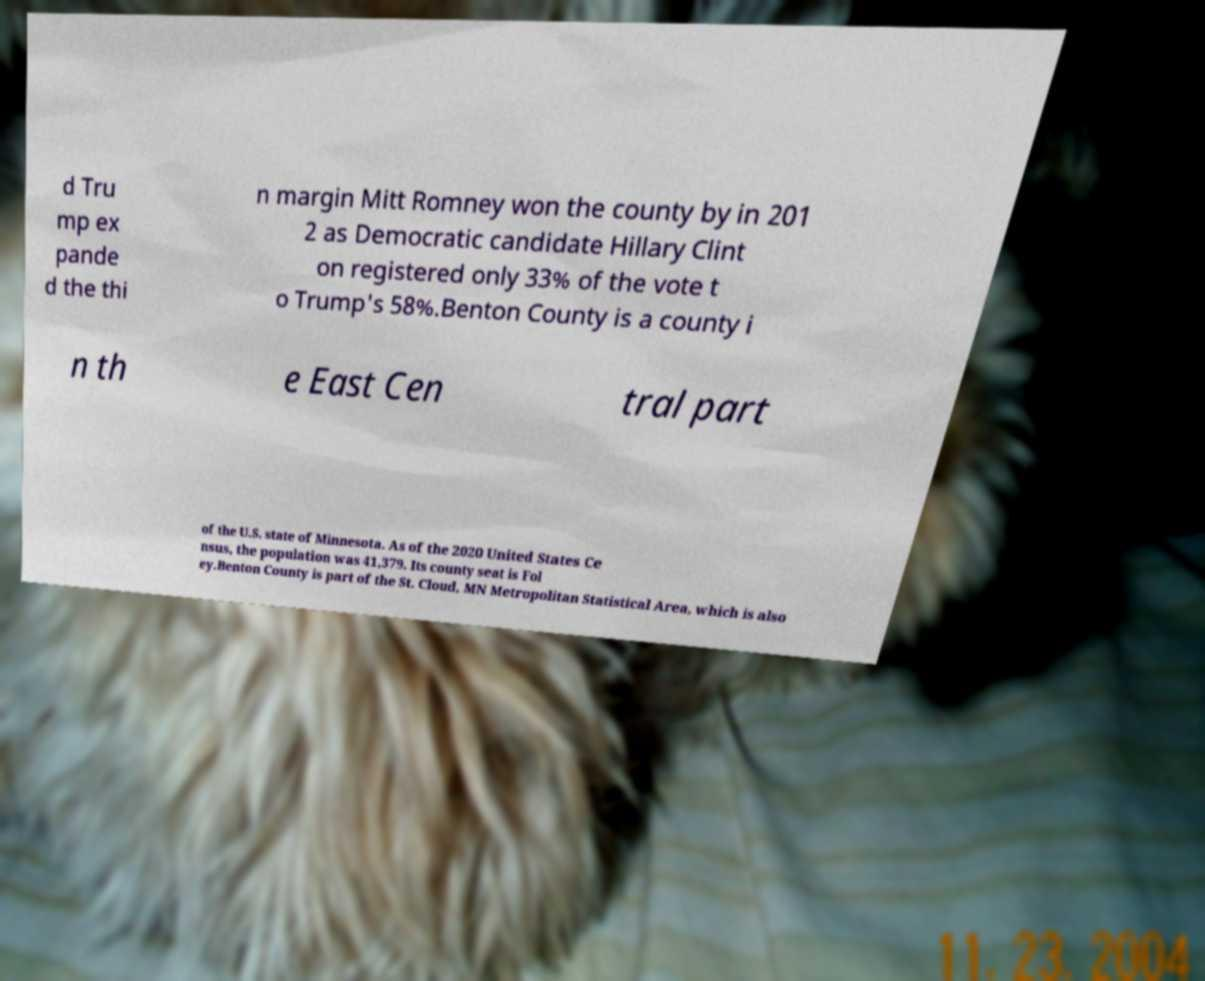What messages or text are displayed in this image? I need them in a readable, typed format. d Tru mp ex pande d the thi n margin Mitt Romney won the county by in 201 2 as Democratic candidate Hillary Clint on registered only 33% of the vote t o Trump's 58%.Benton County is a county i n th e East Cen tral part of the U.S. state of Minnesota. As of the 2020 United States Ce nsus, the population was 41,379. Its county seat is Fol ey.Benton County is part of the St. Cloud, MN Metropolitan Statistical Area, which is also 